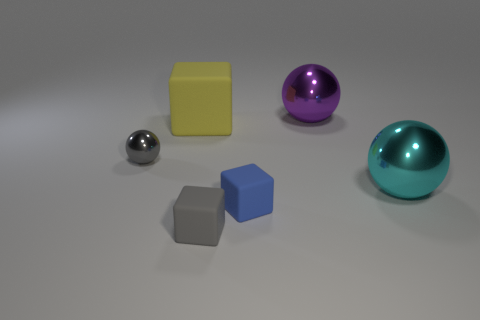The big rubber cube is what color?
Your answer should be very brief. Yellow. What size is the rubber object that is to the left of the tiny gray thing in front of the tiny gray thing to the left of the yellow rubber object?
Keep it short and to the point. Large. There is a object that is in front of the purple thing and right of the tiny blue matte object; what is its color?
Keep it short and to the point. Cyan. Is there any other thing that is the same size as the gray block?
Keep it short and to the point. Yes. Does the large ball in front of the tiny shiny ball have the same color as the big rubber object?
Give a very brief answer. No. What number of cylinders are either small metallic things or cyan metallic things?
Provide a short and direct response. 0. The metallic object left of the gray rubber object has what shape?
Make the answer very short. Sphere. What color is the rubber object that is to the left of the tiny gray object on the right side of the big matte object on the left side of the large purple ball?
Keep it short and to the point. Yellow. Is the material of the big cube the same as the cyan ball?
Offer a terse response. No. What number of purple objects are tiny matte objects or balls?
Provide a succinct answer. 1. 